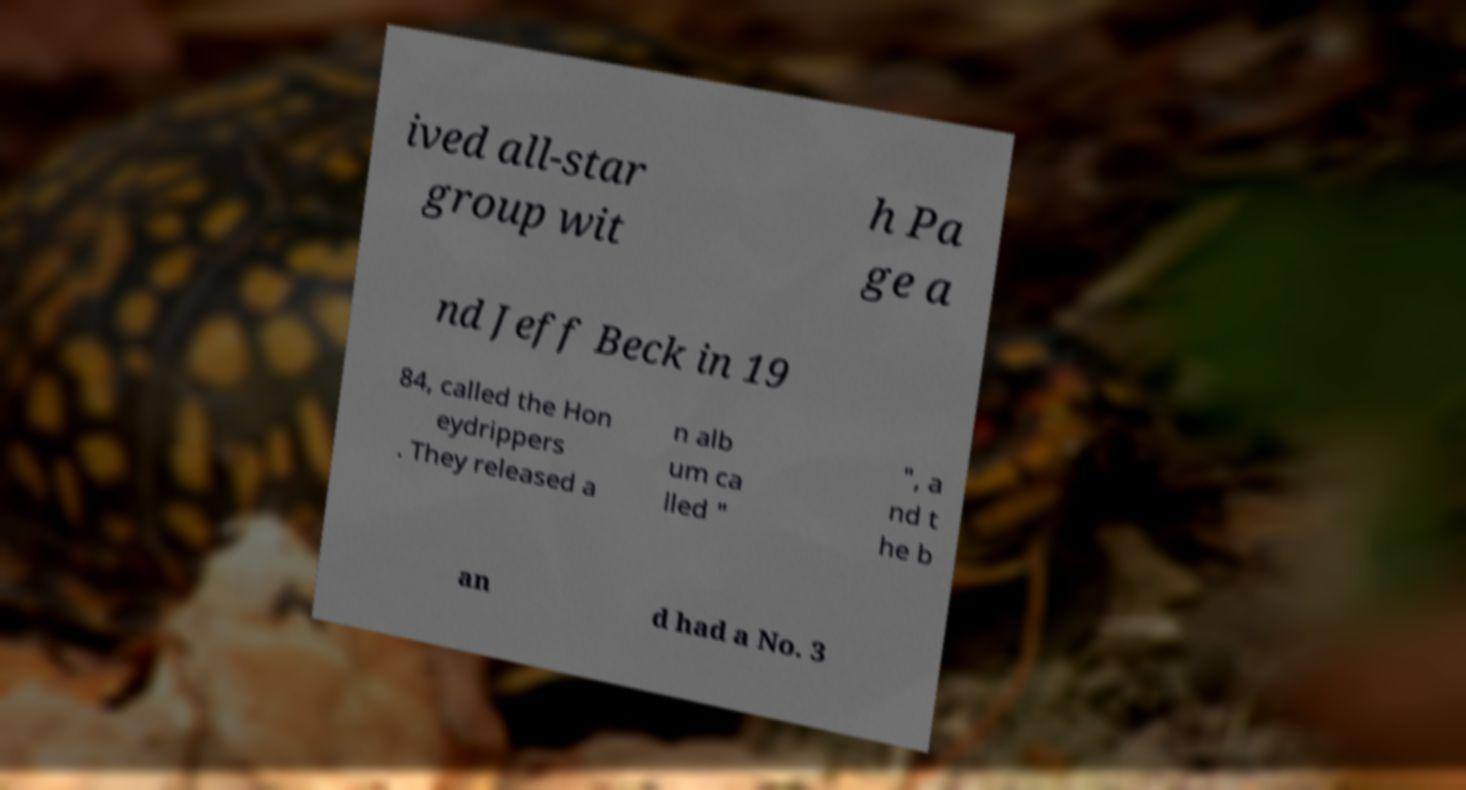Could you extract and type out the text from this image? ived all-star group wit h Pa ge a nd Jeff Beck in 19 84, called the Hon eydrippers . They released a n alb um ca lled " ", a nd t he b an d had a No. 3 